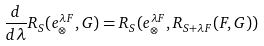<formula> <loc_0><loc_0><loc_500><loc_500>\frac { d } { d \lambda } R _ { S } ( e _ { \otimes } ^ { \lambda F } , G ) = R _ { S } ( e _ { \otimes } ^ { \lambda F } , R _ { S + \lambda F } ( F , G ) )</formula> 